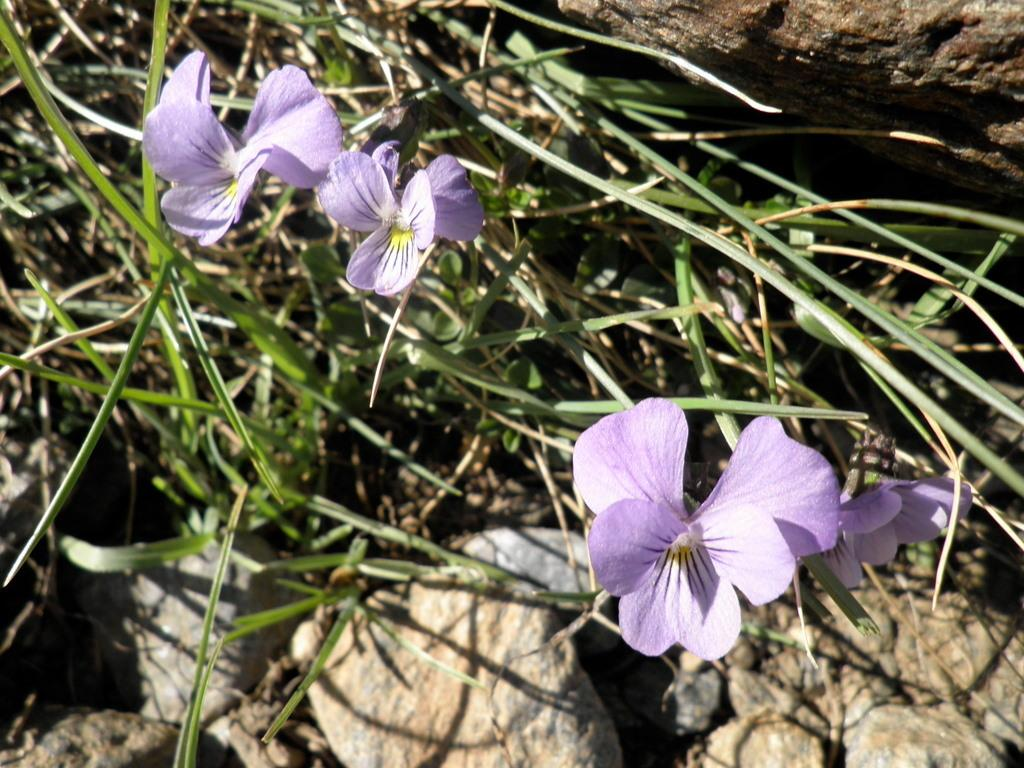What type of plant is visible in the image? There are flowers of a plant in the image. What can be seen in the background of the image? There are stones in the background of the image. What type of neck accessory is the plant wearing in the image? There is no neck accessory present in the image, as the subject is a plant with flowers. 